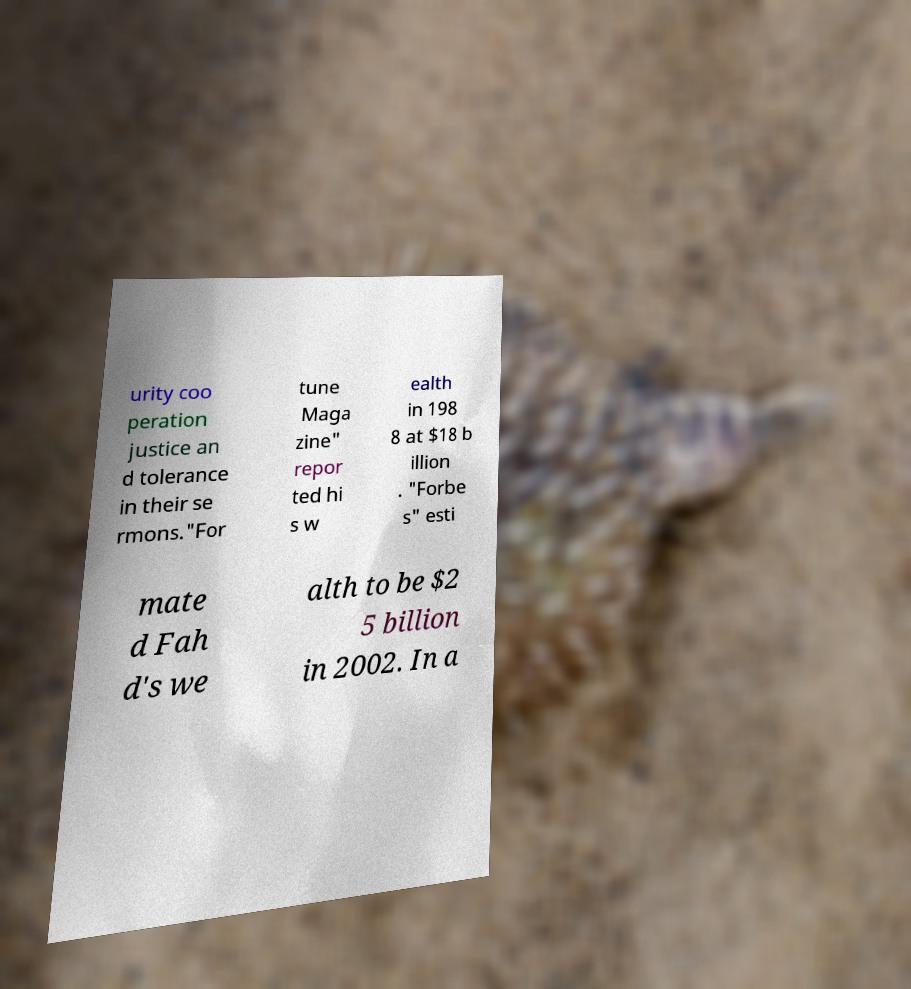Please identify and transcribe the text found in this image. urity coo peration justice an d tolerance in their se rmons."For tune Maga zine" repor ted hi s w ealth in 198 8 at $18 b illion . "Forbe s" esti mate d Fah d's we alth to be $2 5 billion in 2002. In a 